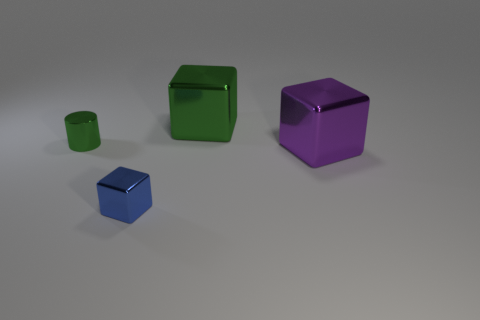Subtract all big cubes. How many cubes are left? 1 Add 2 green blocks. How many objects exist? 6 Subtract all blue cubes. How many cubes are left? 2 Subtract all cubes. How many objects are left? 1 Subtract 1 green blocks. How many objects are left? 3 Subtract all brown blocks. Subtract all brown cylinders. How many blocks are left? 3 Subtract all cyan cylinders. How many brown blocks are left? 0 Subtract all tiny blue shiny spheres. Subtract all large green metallic things. How many objects are left? 3 Add 1 tiny metal things. How many tiny metal things are left? 3 Add 2 big purple metal cubes. How many big purple metal cubes exist? 3 